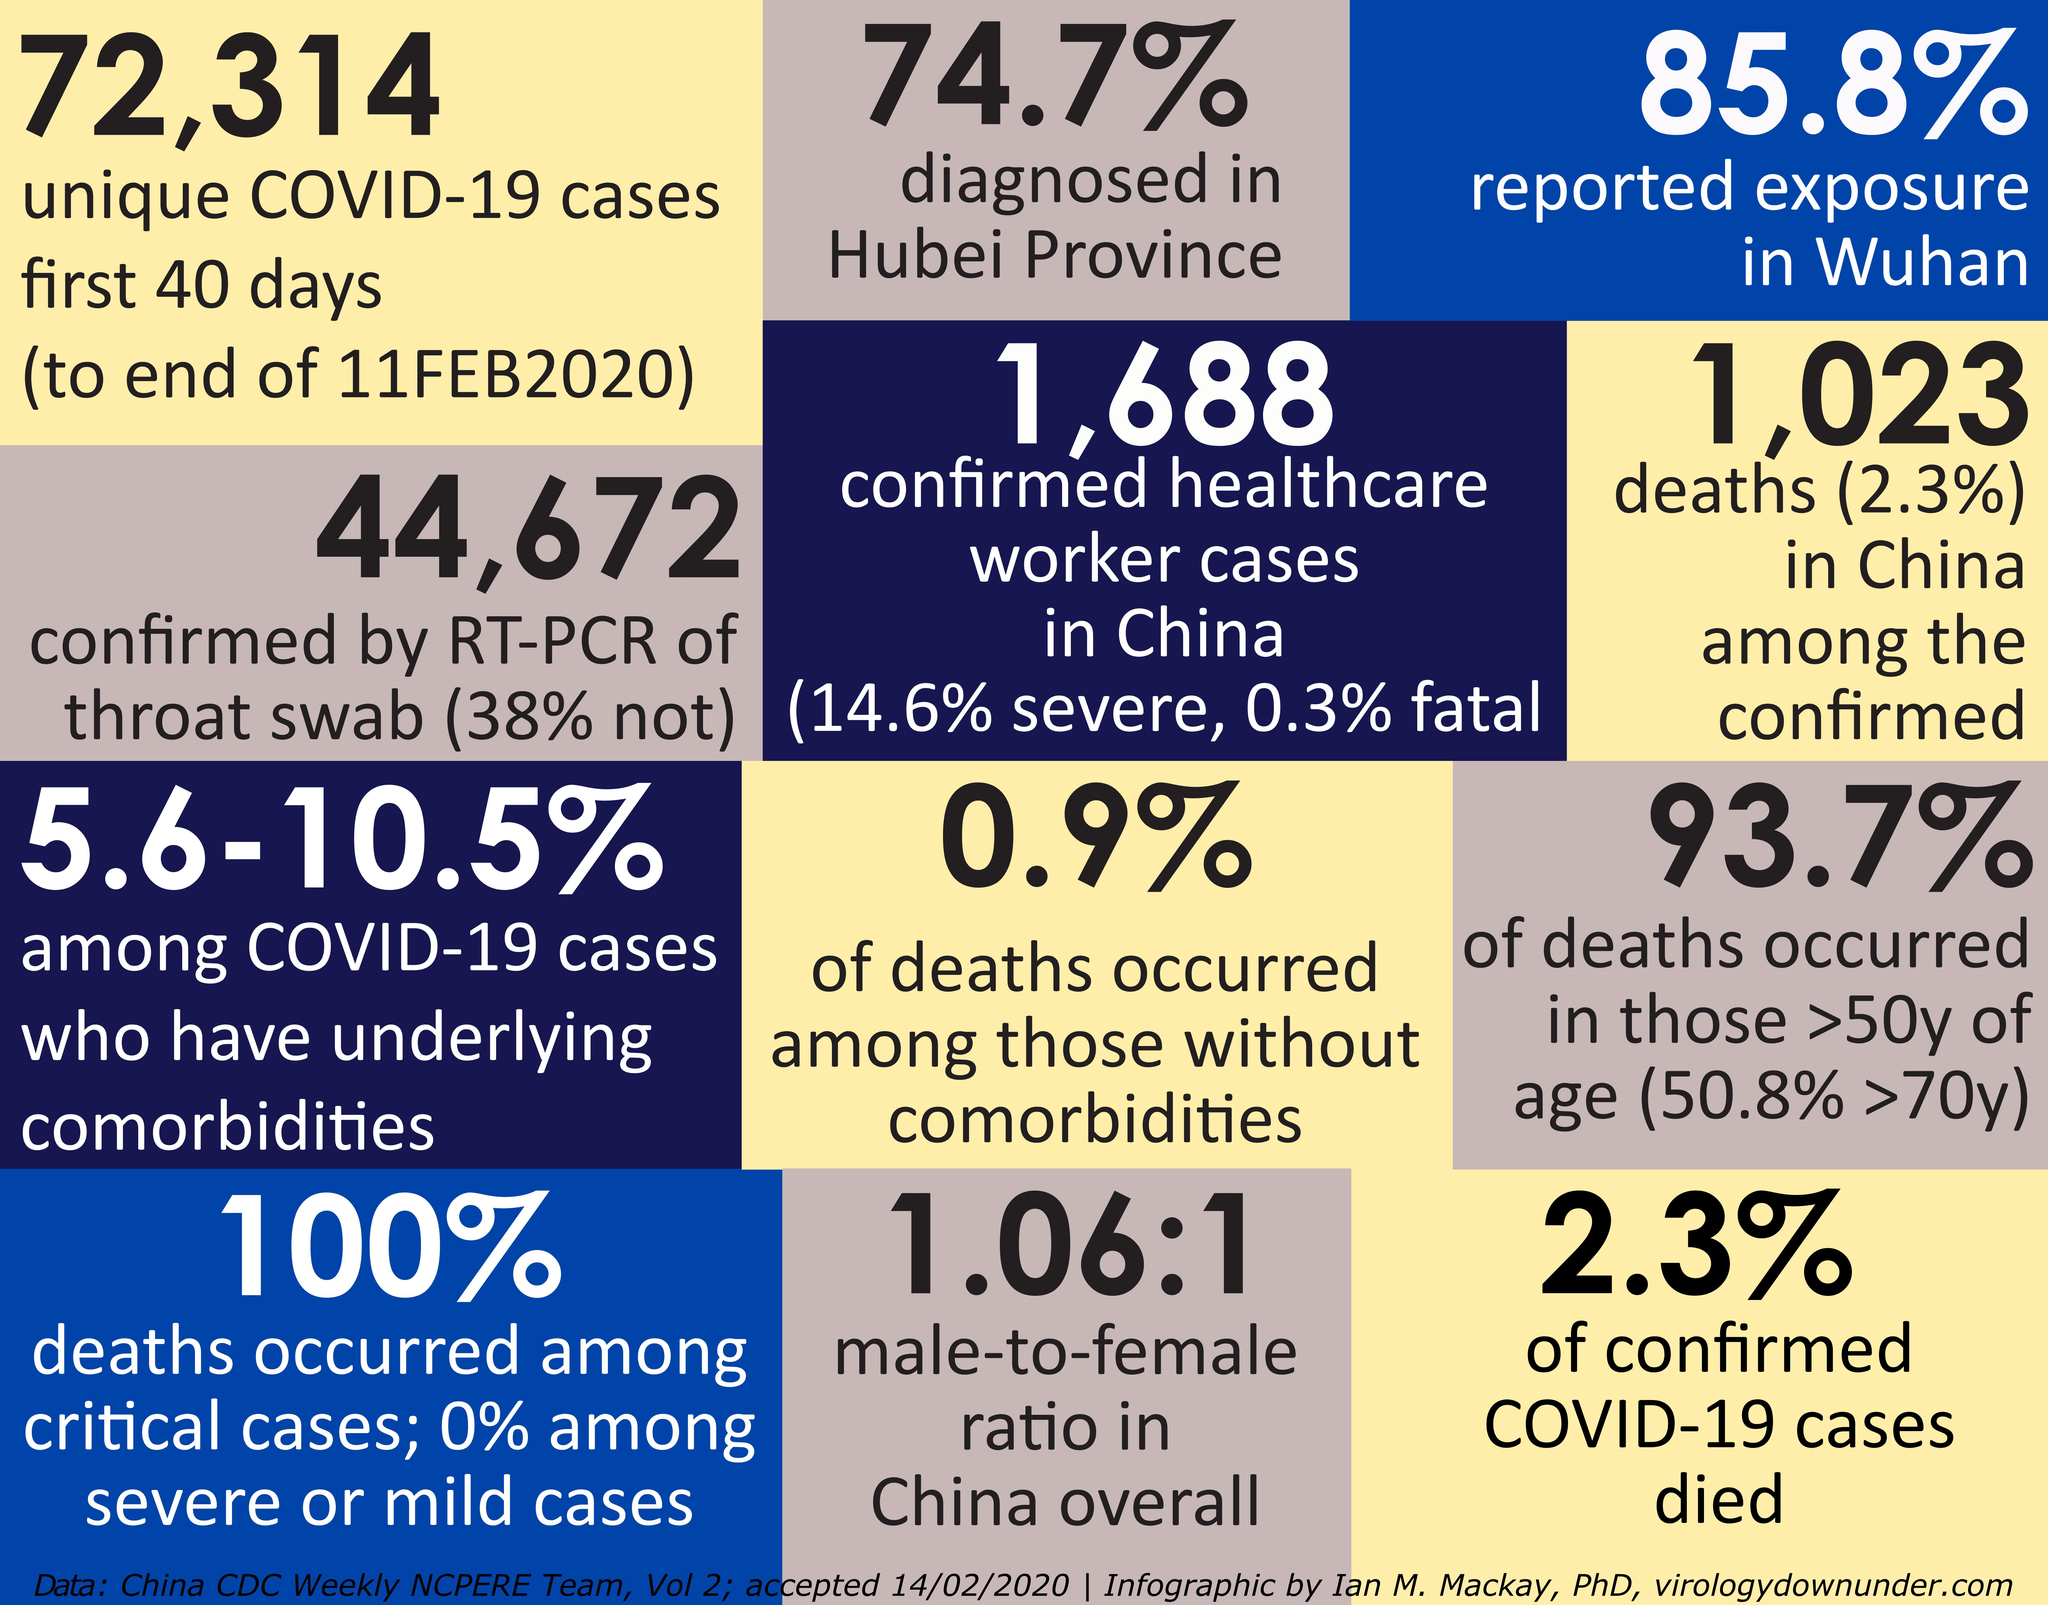Highlight a few significant elements in this photo. According to the latest data, 97.7% of confirmed COVID-19 cases have survived. According to the reported exposure in Wuhan, approximately 14.2% of the exposure has not been reported. A total of 38% of the cases have not been confirmed by RT-PCR of throat swab. 